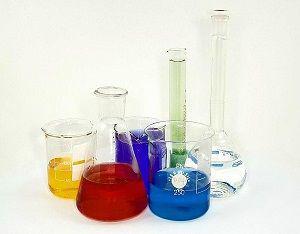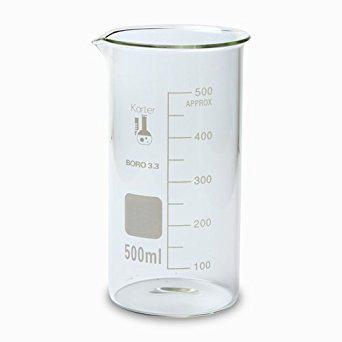The first image is the image on the left, the second image is the image on the right. Assess this claim about the two images: "All of the measuring containers appear to be empty of liquid.". Correct or not? Answer yes or no. No. The first image is the image on the left, the second image is the image on the right. Examine the images to the left and right. Is the description "There are at most two beakers." accurate? Answer yes or no. No. 